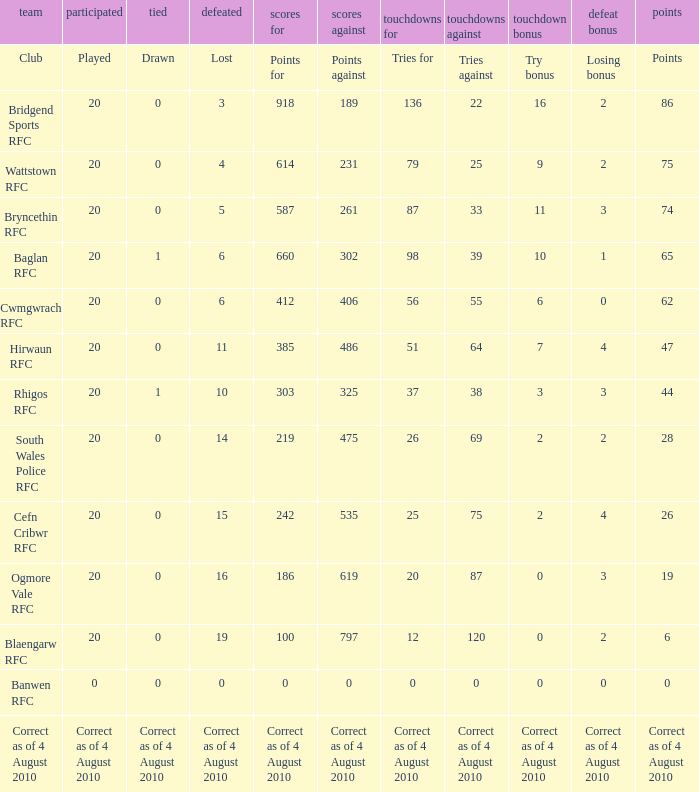What is the points when the club blaengarw rfc? 6.0. 